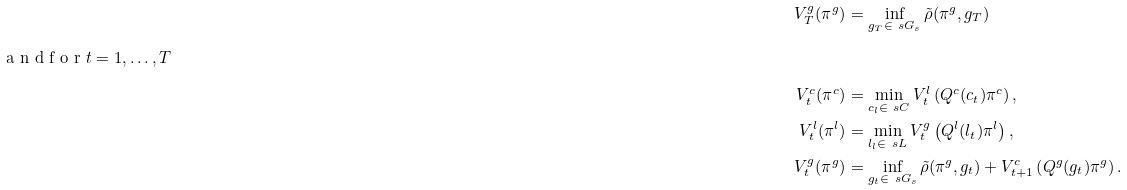<formula> <loc_0><loc_0><loc_500><loc_500>V ^ { g } _ { T } ( \pi ^ { g } ) & = \inf _ { g _ { T } \in \ s G _ { s } } \tilde { \rho } ( \pi ^ { g } , g _ { T } ) \\ \intertext { a n d f o r $ t = 1 , \dots , T $ } V ^ { c } _ { t } ( \pi ^ { c } ) & = \min _ { c _ { l } \in \ s C } V ^ { l } _ { t } \left ( Q ^ { c } ( c _ { t } ) \pi ^ { c } \right ) , \\ V ^ { l } _ { t } ( \pi ^ { l } ) & = \min _ { l _ { l } \in \ s L } V ^ { g } _ { t } \left ( Q ^ { l } ( l _ { t } ) \pi ^ { l } \right ) , \\ V ^ { g } _ { t } ( \pi ^ { g } ) & = \inf _ { g _ { t } \in \ s G _ { s } } \tilde { \rho } ( \pi ^ { g } , g _ { t } ) + V ^ { c } _ { t + 1 } \left ( Q ^ { g } ( g _ { t } ) \pi ^ { g } \right ) .</formula> 